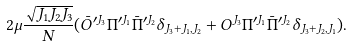Convert formula to latex. <formula><loc_0><loc_0><loc_500><loc_500>2 \mu \frac { \sqrt { J _ { 1 } J _ { 2 } J _ { 3 } } } { N } ( \bar { O } ^ { \prime J _ { 3 } } \Pi ^ { \prime J _ { 1 } } \bar { \Pi } ^ { \prime J _ { 2 } } \delta _ { J _ { 3 } + J _ { 1 } , J _ { 2 } } + O ^ { J _ { 3 } } \Pi ^ { \prime J _ { 1 } } \bar { \Pi } ^ { \prime J _ { 2 } } \delta _ { J _ { 3 } + J _ { 2 } , J _ { 1 } } ) .</formula> 